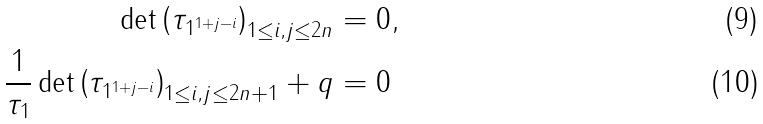Convert formula to latex. <formula><loc_0><loc_0><loc_500><loc_500>\det \left ( \tau _ { 1 ^ { 1 + j - i } } \right ) _ { 1 \leq i , j \leq 2 n } & = 0 , \\ \frac { 1 } { \tau _ { 1 } } \det \left ( \tau _ { 1 ^ { 1 + j - i } } \right ) _ { 1 \leq i , j \leq 2 n + 1 } + q & = 0</formula> 